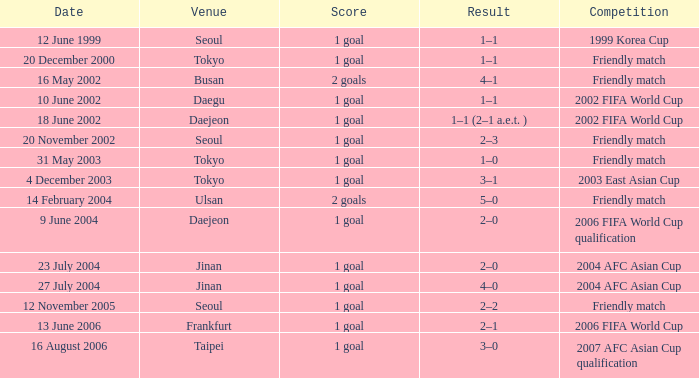Can you identify the contest that happened on the 27th of july, 2004? 2004 AFC Asian Cup. 